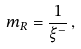Convert formula to latex. <formula><loc_0><loc_0><loc_500><loc_500>m _ { R } = \frac { 1 } { \xi ^ { - } } \, ,</formula> 